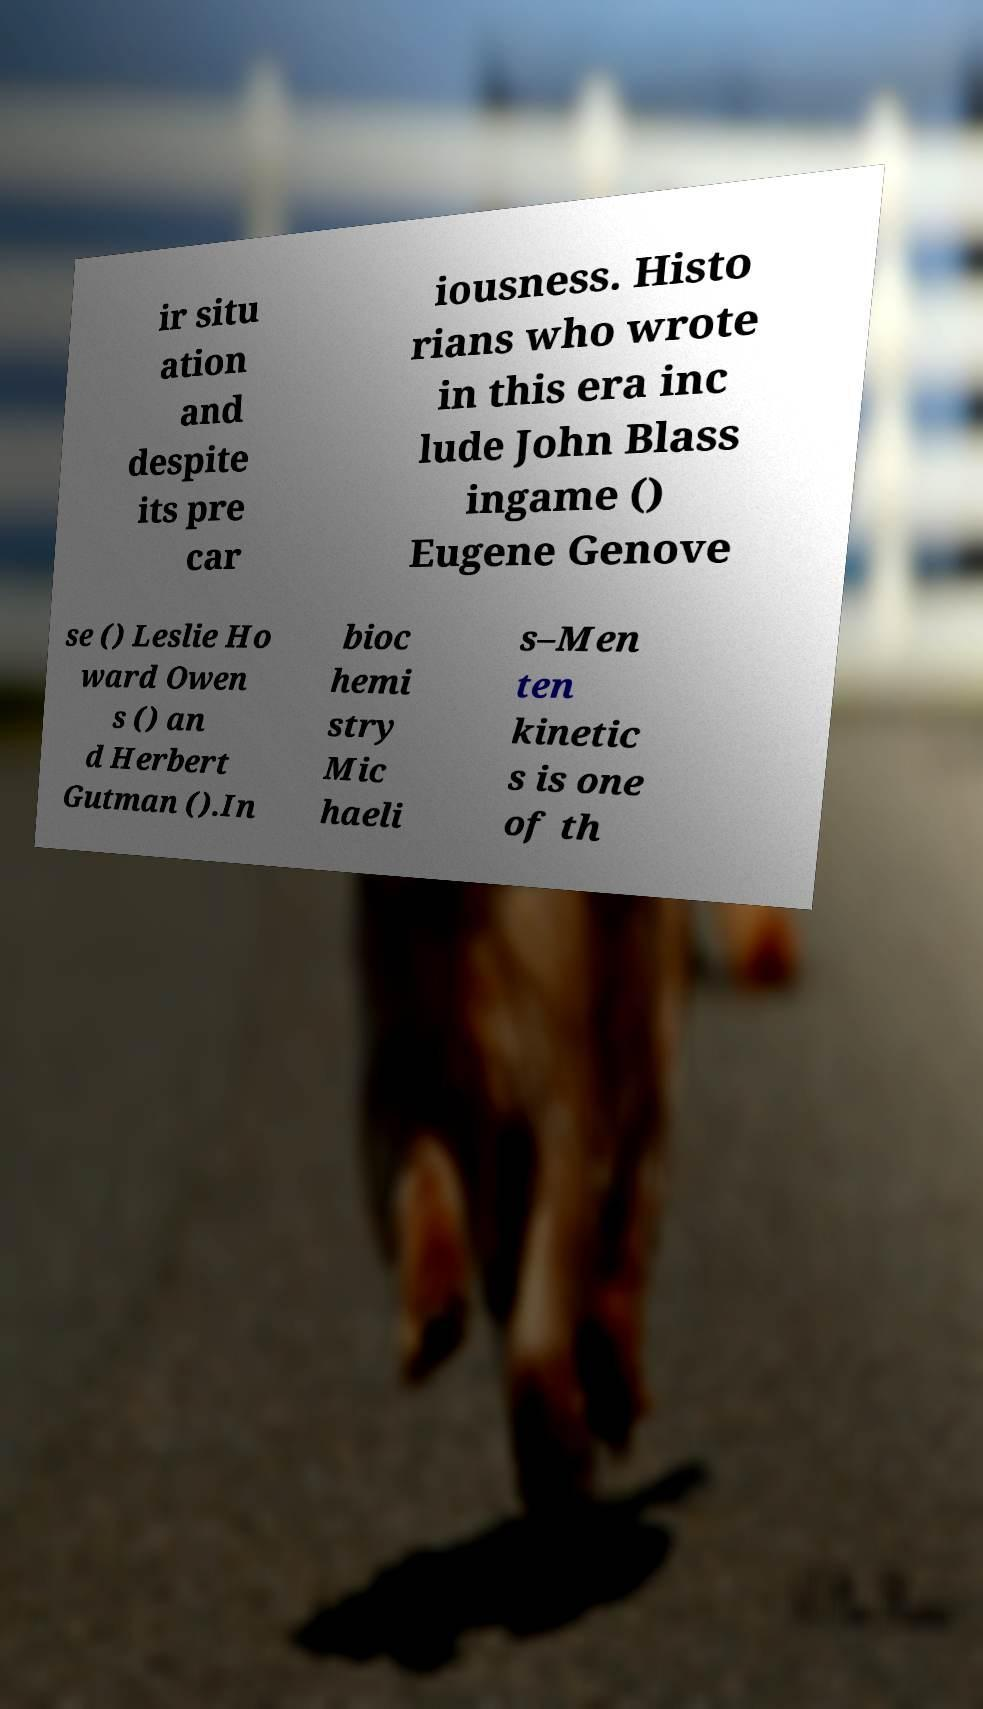Please read and relay the text visible in this image. What does it say? ir situ ation and despite its pre car iousness. Histo rians who wrote in this era inc lude John Blass ingame () Eugene Genove se () Leslie Ho ward Owen s () an d Herbert Gutman ().In bioc hemi stry Mic haeli s–Men ten kinetic s is one of th 